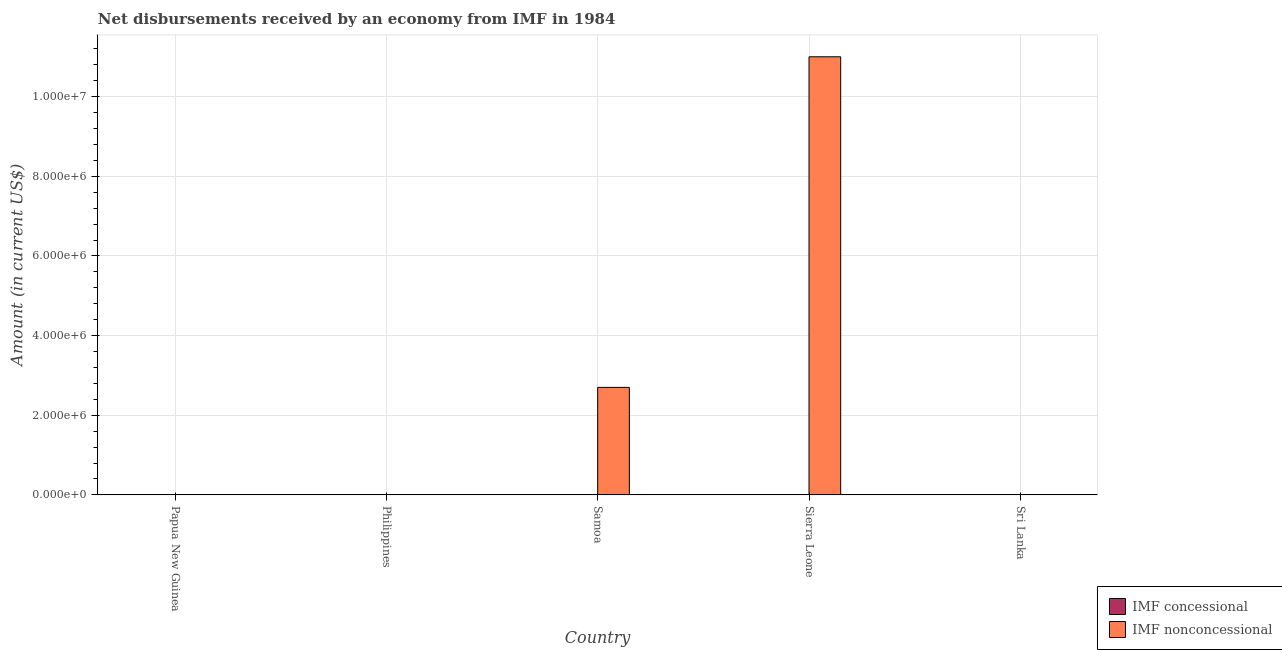How many different coloured bars are there?
Your response must be concise. 1. How many bars are there on the 1st tick from the right?
Ensure brevity in your answer.  0. What is the label of the 4th group of bars from the left?
Provide a succinct answer. Sierra Leone. Across all countries, what is the maximum net non concessional disbursements from imf?
Offer a terse response. 1.10e+07. Across all countries, what is the minimum net concessional disbursements from imf?
Keep it short and to the point. 0. In which country was the net non concessional disbursements from imf maximum?
Ensure brevity in your answer.  Sierra Leone. What is the total net concessional disbursements from imf in the graph?
Keep it short and to the point. 0. What is the difference between the net non concessional disbursements from imf in Sierra Leone and the net concessional disbursements from imf in Papua New Guinea?
Make the answer very short. 1.10e+07. What is the average net non concessional disbursements from imf per country?
Your answer should be compact. 2.74e+06. In how many countries, is the net concessional disbursements from imf greater than 2800000 US$?
Ensure brevity in your answer.  0. What is the difference between the highest and the lowest net non concessional disbursements from imf?
Offer a very short reply. 1.10e+07. In how many countries, is the net concessional disbursements from imf greater than the average net concessional disbursements from imf taken over all countries?
Your answer should be very brief. 0. Are all the bars in the graph horizontal?
Your answer should be compact. No. Are the values on the major ticks of Y-axis written in scientific E-notation?
Offer a terse response. Yes. Does the graph contain any zero values?
Your response must be concise. Yes. Where does the legend appear in the graph?
Offer a terse response. Bottom right. How many legend labels are there?
Offer a very short reply. 2. What is the title of the graph?
Provide a succinct answer. Net disbursements received by an economy from IMF in 1984. What is the label or title of the Y-axis?
Give a very brief answer. Amount (in current US$). What is the Amount (in current US$) in IMF concessional in Papua New Guinea?
Your answer should be compact. 0. What is the Amount (in current US$) of IMF nonconcessional in Papua New Guinea?
Give a very brief answer. 0. What is the Amount (in current US$) of IMF concessional in Philippines?
Provide a short and direct response. 0. What is the Amount (in current US$) in IMF nonconcessional in Philippines?
Ensure brevity in your answer.  0. What is the Amount (in current US$) in IMF concessional in Samoa?
Offer a very short reply. 0. What is the Amount (in current US$) of IMF nonconcessional in Samoa?
Give a very brief answer. 2.70e+06. What is the Amount (in current US$) in IMF nonconcessional in Sierra Leone?
Your answer should be compact. 1.10e+07. What is the Amount (in current US$) in IMF concessional in Sri Lanka?
Keep it short and to the point. 0. Across all countries, what is the maximum Amount (in current US$) in IMF nonconcessional?
Offer a terse response. 1.10e+07. Across all countries, what is the minimum Amount (in current US$) of IMF nonconcessional?
Offer a very short reply. 0. What is the total Amount (in current US$) of IMF nonconcessional in the graph?
Keep it short and to the point. 1.37e+07. What is the difference between the Amount (in current US$) in IMF nonconcessional in Samoa and that in Sierra Leone?
Offer a very short reply. -8.30e+06. What is the average Amount (in current US$) of IMF concessional per country?
Your response must be concise. 0. What is the average Amount (in current US$) in IMF nonconcessional per country?
Offer a very short reply. 2.74e+06. What is the ratio of the Amount (in current US$) of IMF nonconcessional in Samoa to that in Sierra Leone?
Your answer should be very brief. 0.25. What is the difference between the highest and the lowest Amount (in current US$) in IMF nonconcessional?
Offer a terse response. 1.10e+07. 